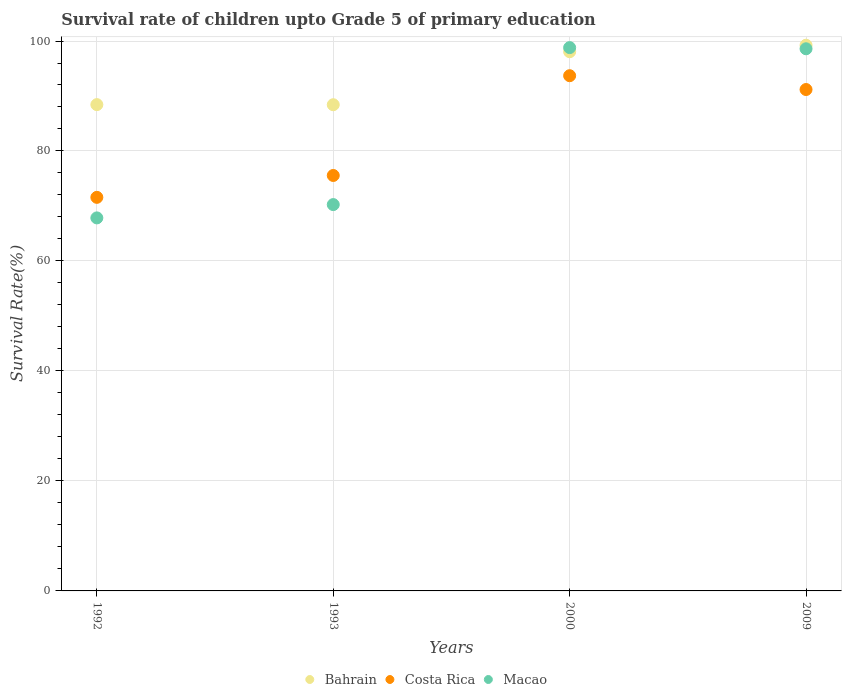Is the number of dotlines equal to the number of legend labels?
Provide a short and direct response. Yes. What is the survival rate of children in Bahrain in 1993?
Keep it short and to the point. 88.41. Across all years, what is the maximum survival rate of children in Costa Rica?
Your response must be concise. 93.69. Across all years, what is the minimum survival rate of children in Macao?
Your answer should be very brief. 67.83. In which year was the survival rate of children in Bahrain maximum?
Your answer should be very brief. 2009. What is the total survival rate of children in Costa Rica in the graph?
Provide a short and direct response. 331.98. What is the difference between the survival rate of children in Macao in 1993 and that in 2009?
Make the answer very short. -28.33. What is the difference between the survival rate of children in Bahrain in 1992 and the survival rate of children in Macao in 2000?
Ensure brevity in your answer.  -10.37. What is the average survival rate of children in Macao per year?
Your response must be concise. 83.87. In the year 2000, what is the difference between the survival rate of children in Bahrain and survival rate of children in Macao?
Offer a terse response. -0.75. In how many years, is the survival rate of children in Costa Rica greater than 92 %?
Provide a succinct answer. 1. What is the ratio of the survival rate of children in Bahrain in 1993 to that in 2009?
Offer a very short reply. 0.89. What is the difference between the highest and the second highest survival rate of children in Bahrain?
Provide a short and direct response. 1.18. What is the difference between the highest and the lowest survival rate of children in Bahrain?
Your answer should be compact. 10.82. In how many years, is the survival rate of children in Bahrain greater than the average survival rate of children in Bahrain taken over all years?
Offer a terse response. 2. Is the sum of the survival rate of children in Macao in 1992 and 1993 greater than the maximum survival rate of children in Bahrain across all years?
Provide a succinct answer. Yes. Is it the case that in every year, the sum of the survival rate of children in Costa Rica and survival rate of children in Macao  is greater than the survival rate of children in Bahrain?
Offer a terse response. Yes. Does the survival rate of children in Macao monotonically increase over the years?
Ensure brevity in your answer.  No. Is the survival rate of children in Bahrain strictly greater than the survival rate of children in Costa Rica over the years?
Ensure brevity in your answer.  Yes. How many years are there in the graph?
Your answer should be compact. 4. Where does the legend appear in the graph?
Give a very brief answer. Bottom center. How are the legend labels stacked?
Give a very brief answer. Horizontal. What is the title of the graph?
Your answer should be very brief. Survival rate of children upto Grade 5 of primary education. Does "Sierra Leone" appear as one of the legend labels in the graph?
Ensure brevity in your answer.  No. What is the label or title of the X-axis?
Keep it short and to the point. Years. What is the label or title of the Y-axis?
Offer a terse response. Survival Rate(%). What is the Survival Rate(%) in Bahrain in 1992?
Provide a succinct answer. 88.43. What is the Survival Rate(%) of Costa Rica in 1992?
Make the answer very short. 71.57. What is the Survival Rate(%) in Macao in 1992?
Your response must be concise. 67.83. What is the Survival Rate(%) in Bahrain in 1993?
Provide a short and direct response. 88.41. What is the Survival Rate(%) of Costa Rica in 1993?
Your answer should be compact. 75.55. What is the Survival Rate(%) in Macao in 1993?
Ensure brevity in your answer.  70.25. What is the Survival Rate(%) in Bahrain in 2000?
Give a very brief answer. 98.05. What is the Survival Rate(%) in Costa Rica in 2000?
Your answer should be compact. 93.69. What is the Survival Rate(%) of Macao in 2000?
Offer a very short reply. 98.8. What is the Survival Rate(%) of Bahrain in 2009?
Keep it short and to the point. 99.24. What is the Survival Rate(%) in Costa Rica in 2009?
Keep it short and to the point. 91.18. What is the Survival Rate(%) in Macao in 2009?
Make the answer very short. 98.59. Across all years, what is the maximum Survival Rate(%) of Bahrain?
Provide a succinct answer. 99.24. Across all years, what is the maximum Survival Rate(%) of Costa Rica?
Make the answer very short. 93.69. Across all years, what is the maximum Survival Rate(%) of Macao?
Keep it short and to the point. 98.8. Across all years, what is the minimum Survival Rate(%) in Bahrain?
Offer a very short reply. 88.41. Across all years, what is the minimum Survival Rate(%) of Costa Rica?
Offer a terse response. 71.57. Across all years, what is the minimum Survival Rate(%) of Macao?
Ensure brevity in your answer.  67.83. What is the total Survival Rate(%) in Bahrain in the graph?
Give a very brief answer. 374.13. What is the total Survival Rate(%) in Costa Rica in the graph?
Your answer should be compact. 331.98. What is the total Survival Rate(%) in Macao in the graph?
Offer a very short reply. 335.47. What is the difference between the Survival Rate(%) in Bahrain in 1992 and that in 1993?
Offer a terse response. 0.02. What is the difference between the Survival Rate(%) in Costa Rica in 1992 and that in 1993?
Your answer should be very brief. -3.98. What is the difference between the Survival Rate(%) of Macao in 1992 and that in 1993?
Your response must be concise. -2.42. What is the difference between the Survival Rate(%) of Bahrain in 1992 and that in 2000?
Give a very brief answer. -9.62. What is the difference between the Survival Rate(%) of Costa Rica in 1992 and that in 2000?
Your answer should be very brief. -22.12. What is the difference between the Survival Rate(%) in Macao in 1992 and that in 2000?
Keep it short and to the point. -30.96. What is the difference between the Survival Rate(%) in Bahrain in 1992 and that in 2009?
Offer a terse response. -10.8. What is the difference between the Survival Rate(%) in Costa Rica in 1992 and that in 2009?
Ensure brevity in your answer.  -19.61. What is the difference between the Survival Rate(%) in Macao in 1992 and that in 2009?
Offer a very short reply. -30.75. What is the difference between the Survival Rate(%) in Bahrain in 1993 and that in 2000?
Offer a terse response. -9.64. What is the difference between the Survival Rate(%) in Costa Rica in 1993 and that in 2000?
Make the answer very short. -18.14. What is the difference between the Survival Rate(%) of Macao in 1993 and that in 2000?
Provide a short and direct response. -28.54. What is the difference between the Survival Rate(%) in Bahrain in 1993 and that in 2009?
Provide a succinct answer. -10.82. What is the difference between the Survival Rate(%) of Costa Rica in 1993 and that in 2009?
Provide a succinct answer. -15.63. What is the difference between the Survival Rate(%) of Macao in 1993 and that in 2009?
Make the answer very short. -28.33. What is the difference between the Survival Rate(%) in Bahrain in 2000 and that in 2009?
Offer a very short reply. -1.18. What is the difference between the Survival Rate(%) of Costa Rica in 2000 and that in 2009?
Your answer should be very brief. 2.51. What is the difference between the Survival Rate(%) of Macao in 2000 and that in 2009?
Give a very brief answer. 0.21. What is the difference between the Survival Rate(%) in Bahrain in 1992 and the Survival Rate(%) in Costa Rica in 1993?
Offer a very short reply. 12.89. What is the difference between the Survival Rate(%) of Bahrain in 1992 and the Survival Rate(%) of Macao in 1993?
Provide a succinct answer. 18.18. What is the difference between the Survival Rate(%) in Costa Rica in 1992 and the Survival Rate(%) in Macao in 1993?
Offer a terse response. 1.32. What is the difference between the Survival Rate(%) in Bahrain in 1992 and the Survival Rate(%) in Costa Rica in 2000?
Provide a succinct answer. -5.26. What is the difference between the Survival Rate(%) of Bahrain in 1992 and the Survival Rate(%) of Macao in 2000?
Keep it short and to the point. -10.37. What is the difference between the Survival Rate(%) in Costa Rica in 1992 and the Survival Rate(%) in Macao in 2000?
Your response must be concise. -27.23. What is the difference between the Survival Rate(%) in Bahrain in 1992 and the Survival Rate(%) in Costa Rica in 2009?
Your answer should be compact. -2.75. What is the difference between the Survival Rate(%) in Bahrain in 1992 and the Survival Rate(%) in Macao in 2009?
Keep it short and to the point. -10.15. What is the difference between the Survival Rate(%) in Costa Rica in 1992 and the Survival Rate(%) in Macao in 2009?
Keep it short and to the point. -27.02. What is the difference between the Survival Rate(%) of Bahrain in 1993 and the Survival Rate(%) of Costa Rica in 2000?
Your response must be concise. -5.28. What is the difference between the Survival Rate(%) of Bahrain in 1993 and the Survival Rate(%) of Macao in 2000?
Keep it short and to the point. -10.38. What is the difference between the Survival Rate(%) of Costa Rica in 1993 and the Survival Rate(%) of Macao in 2000?
Offer a terse response. -23.25. What is the difference between the Survival Rate(%) in Bahrain in 1993 and the Survival Rate(%) in Costa Rica in 2009?
Provide a succinct answer. -2.76. What is the difference between the Survival Rate(%) of Bahrain in 1993 and the Survival Rate(%) of Macao in 2009?
Your answer should be very brief. -10.17. What is the difference between the Survival Rate(%) of Costa Rica in 1993 and the Survival Rate(%) of Macao in 2009?
Your response must be concise. -23.04. What is the difference between the Survival Rate(%) of Bahrain in 2000 and the Survival Rate(%) of Costa Rica in 2009?
Keep it short and to the point. 6.88. What is the difference between the Survival Rate(%) in Bahrain in 2000 and the Survival Rate(%) in Macao in 2009?
Ensure brevity in your answer.  -0.53. What is the difference between the Survival Rate(%) in Costa Rica in 2000 and the Survival Rate(%) in Macao in 2009?
Keep it short and to the point. -4.9. What is the average Survival Rate(%) of Bahrain per year?
Give a very brief answer. 93.53. What is the average Survival Rate(%) of Costa Rica per year?
Provide a short and direct response. 83. What is the average Survival Rate(%) of Macao per year?
Make the answer very short. 83.87. In the year 1992, what is the difference between the Survival Rate(%) of Bahrain and Survival Rate(%) of Costa Rica?
Offer a very short reply. 16.86. In the year 1992, what is the difference between the Survival Rate(%) of Bahrain and Survival Rate(%) of Macao?
Offer a terse response. 20.6. In the year 1992, what is the difference between the Survival Rate(%) of Costa Rica and Survival Rate(%) of Macao?
Make the answer very short. 3.74. In the year 1993, what is the difference between the Survival Rate(%) of Bahrain and Survival Rate(%) of Costa Rica?
Provide a short and direct response. 12.87. In the year 1993, what is the difference between the Survival Rate(%) in Bahrain and Survival Rate(%) in Macao?
Give a very brief answer. 18.16. In the year 1993, what is the difference between the Survival Rate(%) of Costa Rica and Survival Rate(%) of Macao?
Your response must be concise. 5.29. In the year 2000, what is the difference between the Survival Rate(%) in Bahrain and Survival Rate(%) in Costa Rica?
Offer a terse response. 4.36. In the year 2000, what is the difference between the Survival Rate(%) in Bahrain and Survival Rate(%) in Macao?
Provide a short and direct response. -0.75. In the year 2000, what is the difference between the Survival Rate(%) in Costa Rica and Survival Rate(%) in Macao?
Give a very brief answer. -5.11. In the year 2009, what is the difference between the Survival Rate(%) of Bahrain and Survival Rate(%) of Costa Rica?
Make the answer very short. 8.06. In the year 2009, what is the difference between the Survival Rate(%) of Bahrain and Survival Rate(%) of Macao?
Provide a short and direct response. 0.65. In the year 2009, what is the difference between the Survival Rate(%) of Costa Rica and Survival Rate(%) of Macao?
Keep it short and to the point. -7.41. What is the ratio of the Survival Rate(%) of Costa Rica in 1992 to that in 1993?
Give a very brief answer. 0.95. What is the ratio of the Survival Rate(%) of Macao in 1992 to that in 1993?
Your answer should be compact. 0.97. What is the ratio of the Survival Rate(%) of Bahrain in 1992 to that in 2000?
Make the answer very short. 0.9. What is the ratio of the Survival Rate(%) in Costa Rica in 1992 to that in 2000?
Your answer should be very brief. 0.76. What is the ratio of the Survival Rate(%) in Macao in 1992 to that in 2000?
Provide a short and direct response. 0.69. What is the ratio of the Survival Rate(%) in Bahrain in 1992 to that in 2009?
Ensure brevity in your answer.  0.89. What is the ratio of the Survival Rate(%) in Costa Rica in 1992 to that in 2009?
Keep it short and to the point. 0.79. What is the ratio of the Survival Rate(%) in Macao in 1992 to that in 2009?
Offer a very short reply. 0.69. What is the ratio of the Survival Rate(%) of Bahrain in 1993 to that in 2000?
Your answer should be compact. 0.9. What is the ratio of the Survival Rate(%) of Costa Rica in 1993 to that in 2000?
Offer a terse response. 0.81. What is the ratio of the Survival Rate(%) of Macao in 1993 to that in 2000?
Give a very brief answer. 0.71. What is the ratio of the Survival Rate(%) in Bahrain in 1993 to that in 2009?
Offer a very short reply. 0.89. What is the ratio of the Survival Rate(%) of Costa Rica in 1993 to that in 2009?
Your answer should be very brief. 0.83. What is the ratio of the Survival Rate(%) in Macao in 1993 to that in 2009?
Give a very brief answer. 0.71. What is the ratio of the Survival Rate(%) in Bahrain in 2000 to that in 2009?
Keep it short and to the point. 0.99. What is the ratio of the Survival Rate(%) in Costa Rica in 2000 to that in 2009?
Provide a succinct answer. 1.03. What is the difference between the highest and the second highest Survival Rate(%) in Bahrain?
Your response must be concise. 1.18. What is the difference between the highest and the second highest Survival Rate(%) of Costa Rica?
Provide a succinct answer. 2.51. What is the difference between the highest and the second highest Survival Rate(%) of Macao?
Offer a very short reply. 0.21. What is the difference between the highest and the lowest Survival Rate(%) in Bahrain?
Offer a terse response. 10.82. What is the difference between the highest and the lowest Survival Rate(%) in Costa Rica?
Keep it short and to the point. 22.12. What is the difference between the highest and the lowest Survival Rate(%) of Macao?
Keep it short and to the point. 30.96. 